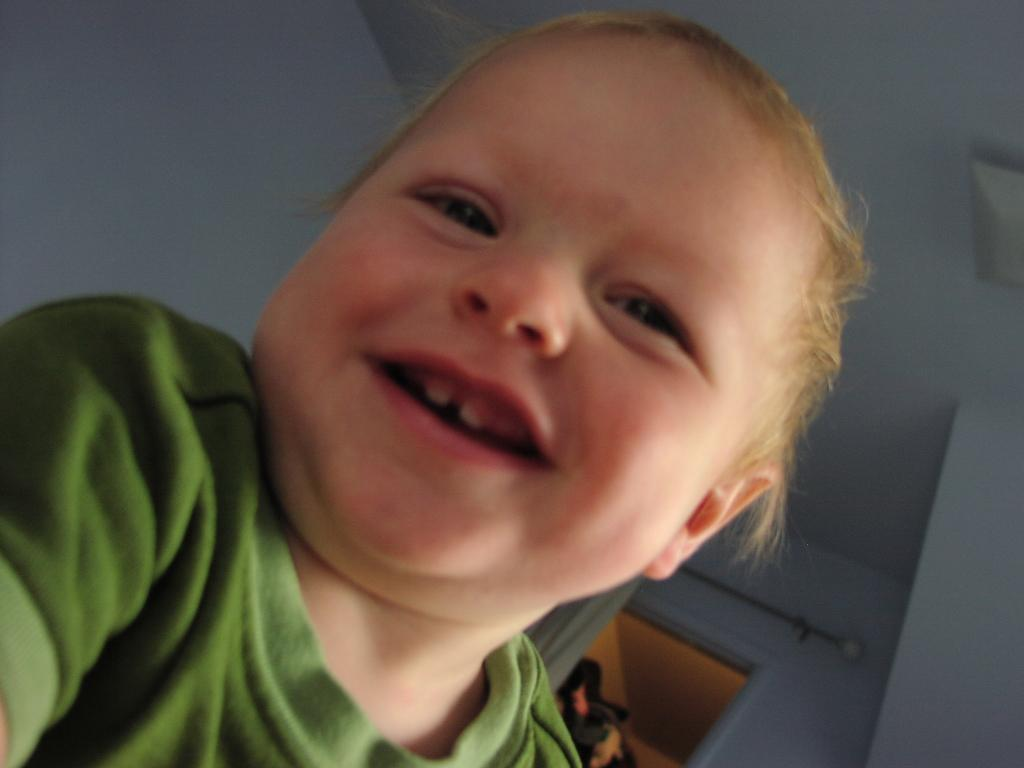What is the main subject of the image? There is a child in the image. What is the child wearing? The child is wearing a green dress. What is the child's facial expression? The child is smiling. What can be seen in the background of the image? There is a door in the background, and the ceiling and walls are white. How many chairs are visible in the image? There are no chairs present in the image. What record is the child breaking in the image? There is no record-breaking activity depicted in the image; the child is simply smiling while wearing a green dress. 